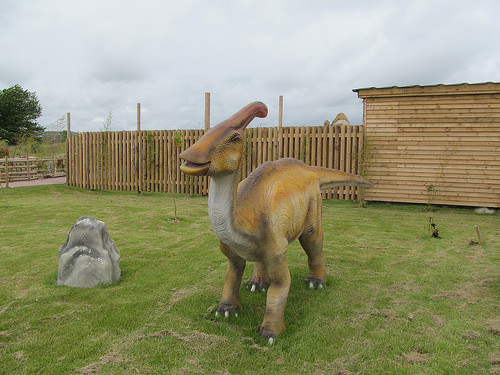<image>
Is the dinosaur next to the rock? Yes. The dinosaur is positioned adjacent to the rock, located nearby in the same general area. 